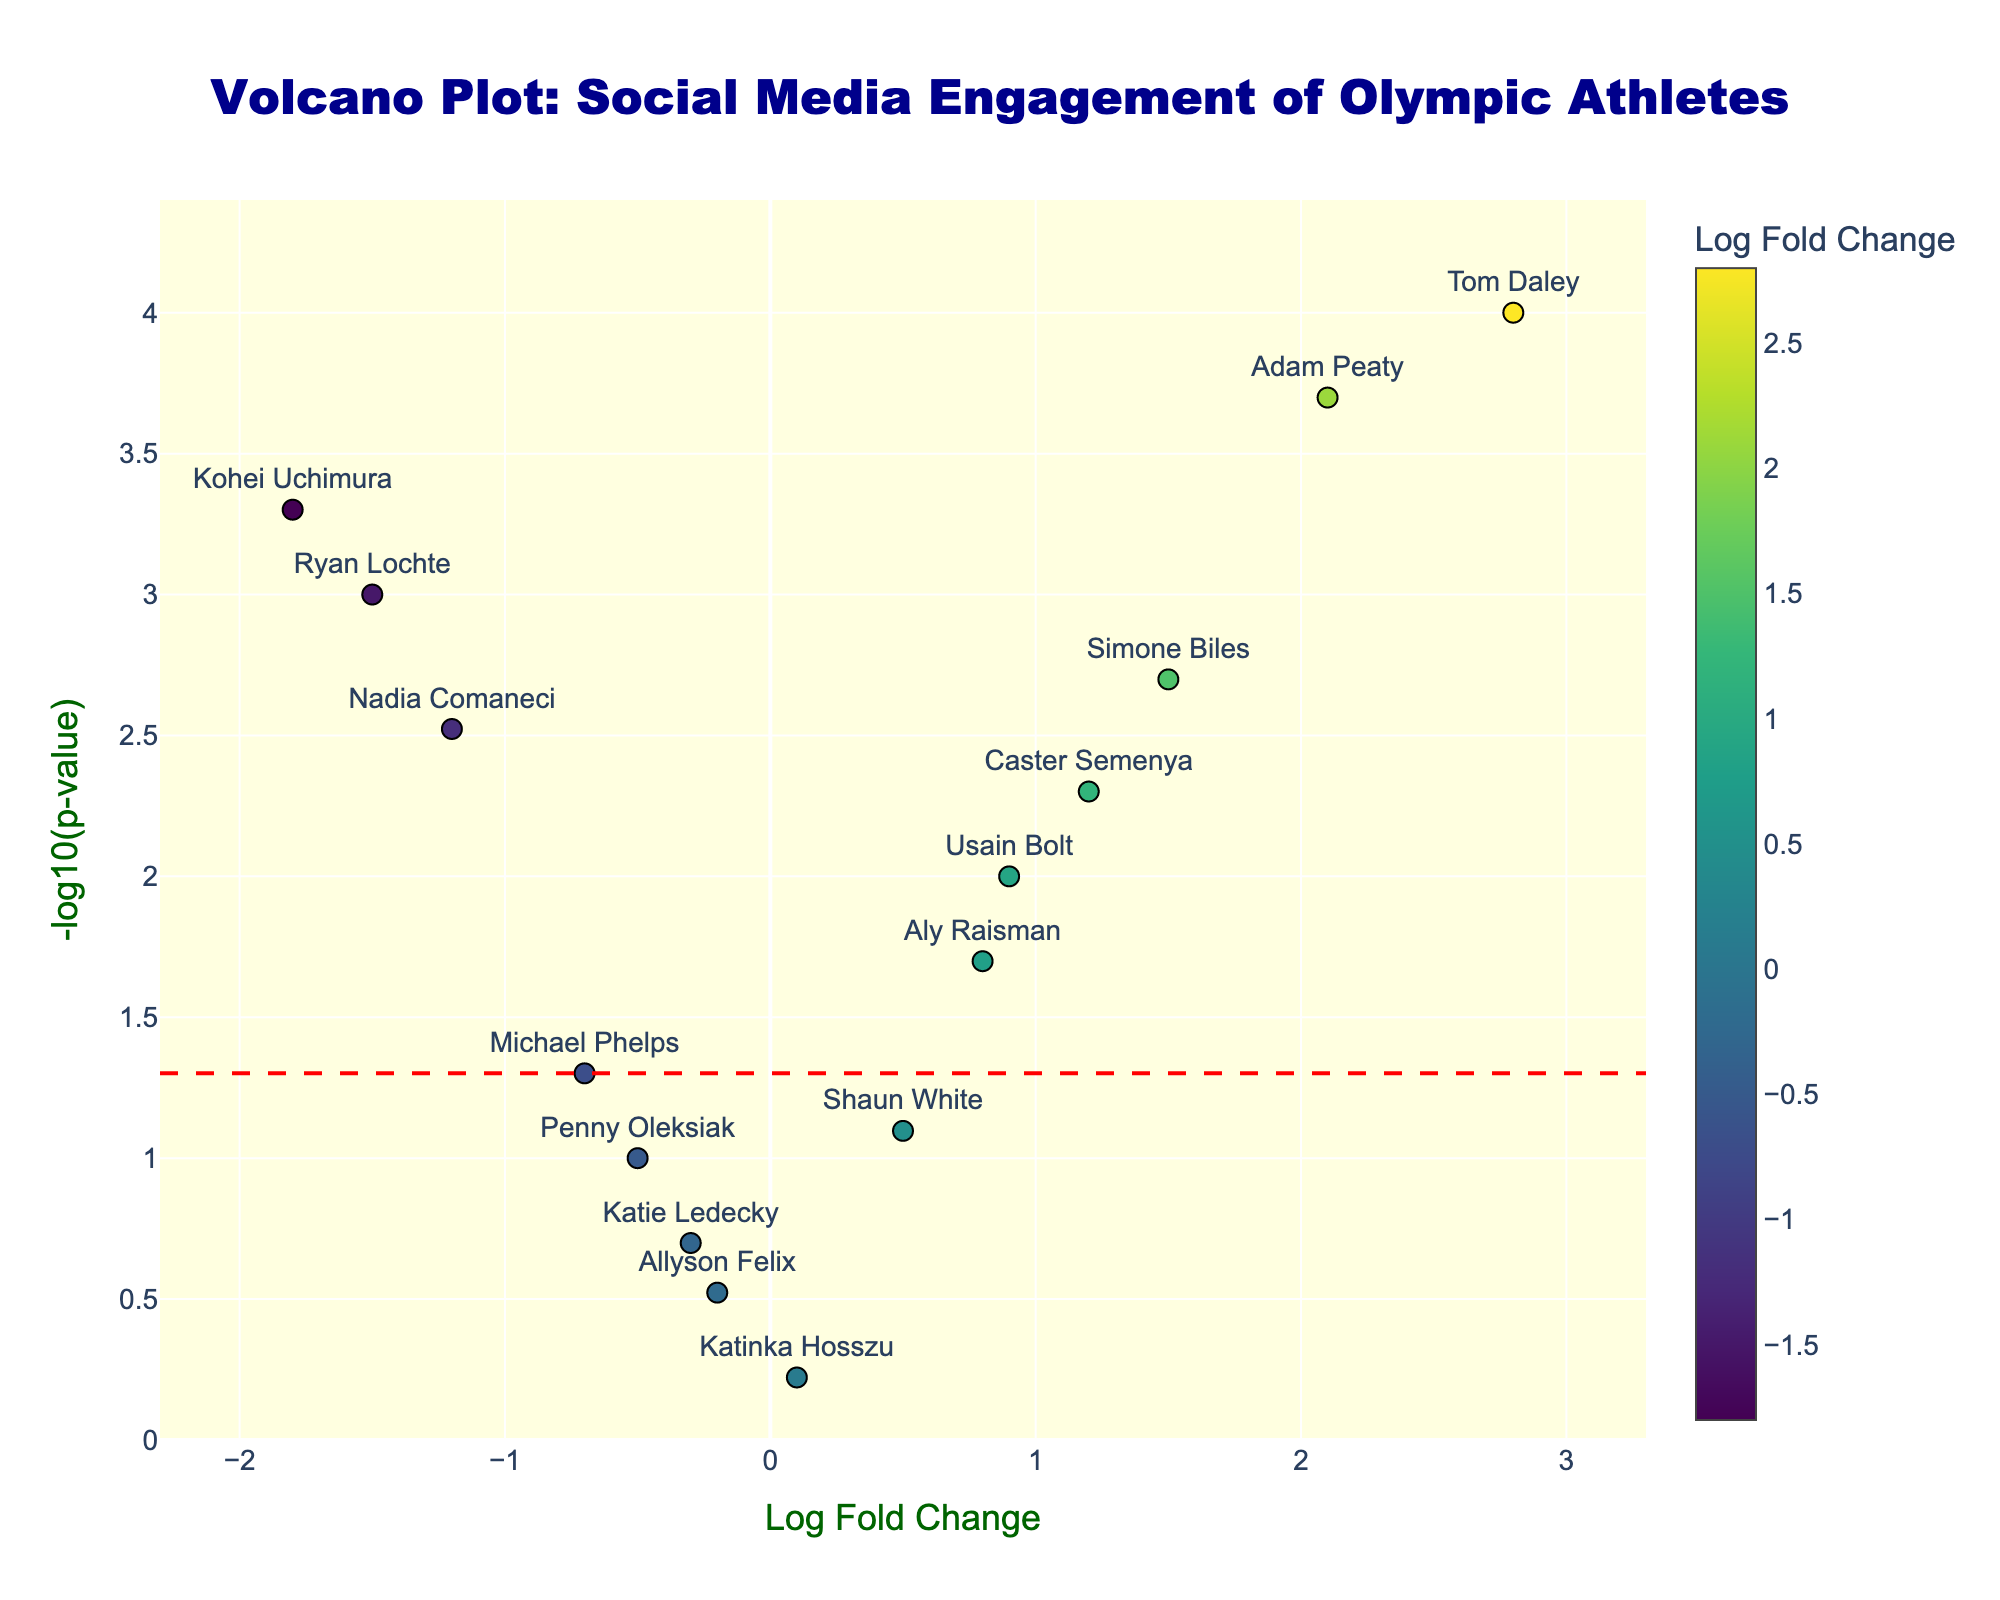What is the title of the figure? The title of the figure is located at the top and is usually in larger, bold text.
Answer: Volcano Plot: Social Media Engagement of Olympic Athletes Which athlete has the highest log fold change? By inspecting the x-axis, look for the point furthest to the right. Additionally, hovering over the points reveals the athlete's name. Tom Daley is located furthest to the right.
Answer: Tom Daley How many athletes have a negative log fold change? Points with a negative log fold change are located to the left of the zero mark on the x-axis. There are 6 athletes to the left of the zero mark.
Answer: 6 Which athlete has the largest -log10(p-value)? By inspecting the y-axis, look for the point highest on the plot. Hover over this point reveals the athlete's name. Tom Daley is in the highest position.
Answer: Tom Daley How many athletes have a -log10(p-value) greater than 2? Points with a -log10(p-value) greater than 2 are located above the line marking 2 on the y-axis (approximately p-value < 0.01). There are 6 athletes above this line.
Answer: 6 Which athlete has the smallest -log10(p-value) among those with a positive log fold change? First, identify the points to the right of zero on the x-axis. Among these, find the point closest to the bottom of the plot. Usain Bolt is the lowest.
Answer: Usain Bolt Identify an athlete with a negative log fold change and a p-value close to 0.05. Points with a p-value close to 0.05 are near the horizontal red line. Michael Phelps is one of the athletes with these characteristics.
Answer: Michael Phelps Is there any athlete with a log fold change near zero and a significant p-value (below 0.05)? Near zero on the x-axis (log fold change) and below the red line (significant p-value) is where we should look. No athlete fits both criteria exactly.
Answer: No Compare Tom Daley's social media engagement with Adam Peaty's. Who has a higher fold change, and who is more significant? Tom Daley has a higher log fold change (2.8 vs. 2.1) and is also more significant since he is higher on the y-axis (-log10(p-value)).
Answer: Tom Daley for both Which athlete with a negative log fold change shows the highest significance? Among the points on the left of the zero line, find the highest one on the y-axis. Kohei Uchimura is the highest among these points.
Answer: Kohei Uchimura 